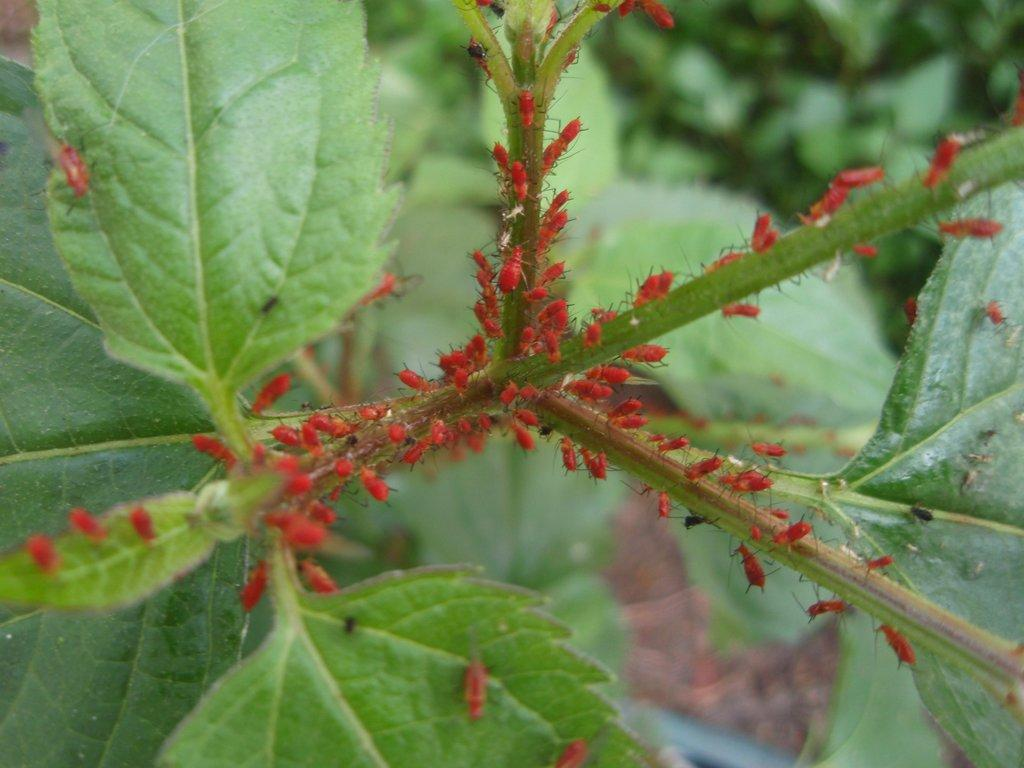What type of living organisms can be seen in the image? Plants are visible in the image. Are there any other creatures interacting with the plants? Yes, insects are present on the leaves and stems of a plant in the image. What type of lamp can be seen illuminating the pie in the image? There is no lamp or pie present in the image; it only features plants and insects. 